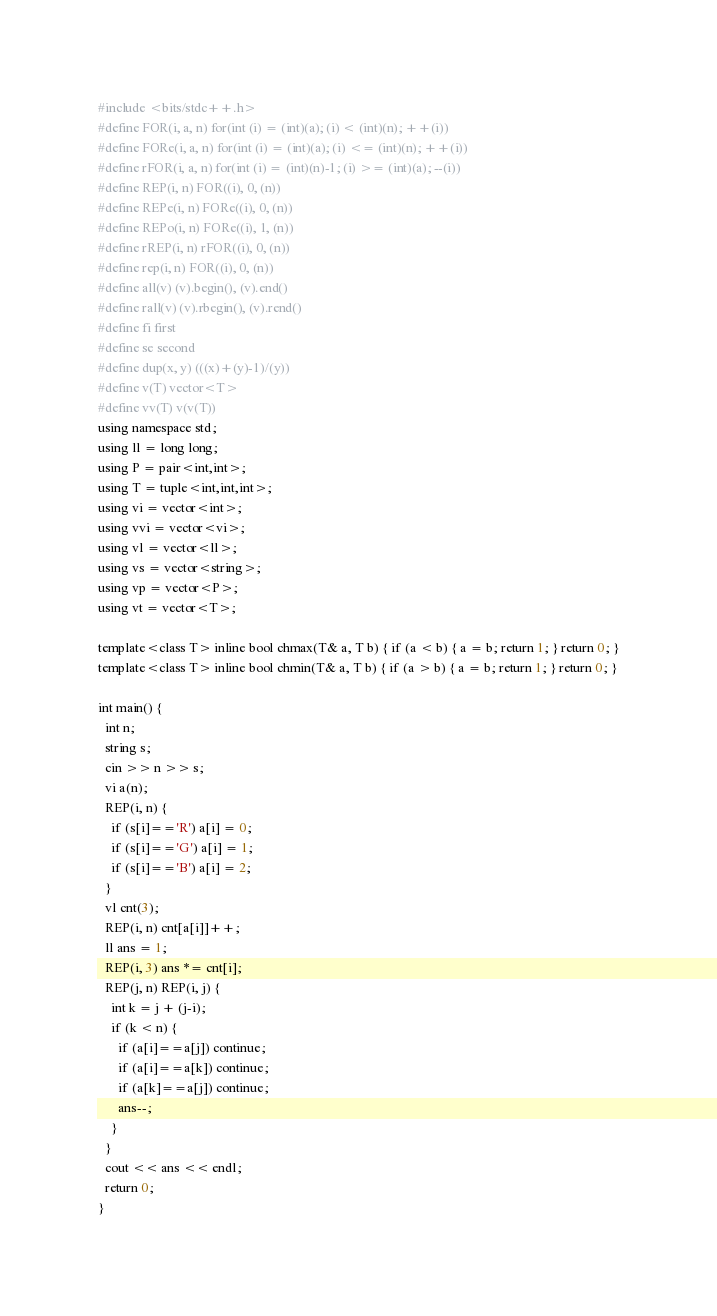<code> <loc_0><loc_0><loc_500><loc_500><_C++_>#include <bits/stdc++.h>
#define FOR(i, a, n) for(int (i) = (int)(a); (i) < (int)(n); ++(i))
#define FORe(i, a, n) for(int (i) = (int)(a); (i) <= (int)(n); ++(i))
#define rFOR(i, a, n) for(int (i) = (int)(n)-1; (i) >= (int)(a); --(i))
#define REP(i, n) FOR((i), 0, (n))
#define REPe(i, n) FORe((i), 0, (n))
#define REPo(i, n) FORe((i), 1, (n))
#define rREP(i, n) rFOR((i), 0, (n))
#define rep(i, n) FOR((i), 0, (n))
#define all(v) (v).begin(), (v).end()
#define rall(v) (v).rbegin(), (v).rend()
#define fi first
#define se second
#define dup(x, y) (((x)+(y)-1)/(y))
#define v(T) vector<T>
#define vv(T) v(v(T))
using namespace std;
using ll = long long;
using P = pair<int,int>;
using T = tuple<int,int,int>;
using vi = vector<int>;
using vvi = vector<vi>;
using vl = vector<ll>;
using vs = vector<string>;
using vp = vector<P>;
using vt = vector<T>;

template<class T> inline bool chmax(T& a, T b) { if (a < b) { a = b; return 1; } return 0; }
template<class T> inline bool chmin(T& a, T b) { if (a > b) { a = b; return 1; } return 0; }

int main() {
  int n;
  string s;
  cin >> n >> s;
  vi a(n);
  REP(i, n) {
    if (s[i]=='R') a[i] = 0;
    if (s[i]=='G') a[i] = 1;
    if (s[i]=='B') a[i] = 2;
  }
  vl cnt(3);
  REP(i, n) cnt[a[i]]++;
  ll ans = 1;
  REP(i, 3) ans *= cnt[i];
  REP(j, n) REP(i, j) {
    int k = j + (j-i);
    if (k < n) {
      if (a[i]==a[j]) continue;
      if (a[i]==a[k]) continue;
      if (a[k]==a[j]) continue;
      ans--;
    }
  }
  cout << ans << endl;
  return 0;
}</code> 